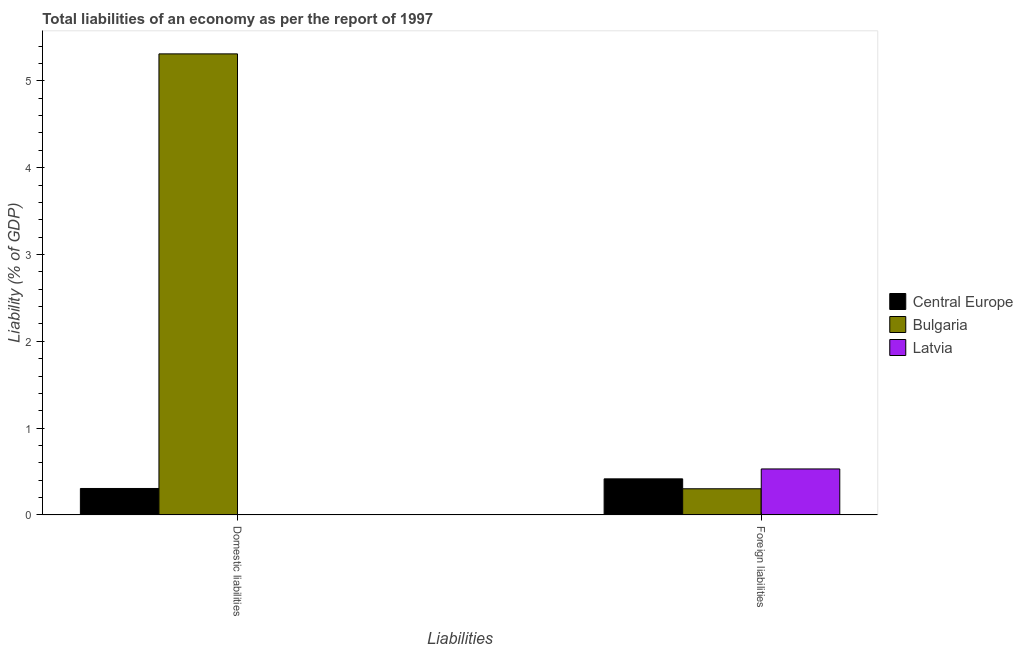How many different coloured bars are there?
Make the answer very short. 3. How many groups of bars are there?
Your response must be concise. 2. Are the number of bars per tick equal to the number of legend labels?
Keep it short and to the point. No. Are the number of bars on each tick of the X-axis equal?
Your response must be concise. No. How many bars are there on the 2nd tick from the right?
Give a very brief answer. 2. What is the label of the 2nd group of bars from the left?
Offer a terse response. Foreign liabilities. What is the incurrence of domestic liabilities in Bulgaria?
Make the answer very short. 5.31. Across all countries, what is the maximum incurrence of foreign liabilities?
Provide a short and direct response. 0.53. Across all countries, what is the minimum incurrence of domestic liabilities?
Your answer should be very brief. 0. In which country was the incurrence of foreign liabilities maximum?
Your answer should be very brief. Latvia. What is the total incurrence of foreign liabilities in the graph?
Your answer should be compact. 1.25. What is the difference between the incurrence of foreign liabilities in Latvia and that in Central Europe?
Give a very brief answer. 0.11. What is the difference between the incurrence of domestic liabilities in Latvia and the incurrence of foreign liabilities in Central Europe?
Offer a terse response. -0.42. What is the average incurrence of domestic liabilities per country?
Give a very brief answer. 1.87. What is the difference between the incurrence of foreign liabilities and incurrence of domestic liabilities in Central Europe?
Provide a short and direct response. 0.11. What is the ratio of the incurrence of foreign liabilities in Bulgaria to that in Central Europe?
Provide a succinct answer. 0.73. Is the incurrence of foreign liabilities in Central Europe less than that in Bulgaria?
Keep it short and to the point. No. Are all the bars in the graph horizontal?
Offer a very short reply. No. Are the values on the major ticks of Y-axis written in scientific E-notation?
Offer a very short reply. No. Does the graph contain grids?
Your answer should be very brief. No. How many legend labels are there?
Your answer should be compact. 3. How are the legend labels stacked?
Provide a succinct answer. Vertical. What is the title of the graph?
Give a very brief answer. Total liabilities of an economy as per the report of 1997. Does "Cuba" appear as one of the legend labels in the graph?
Offer a very short reply. No. What is the label or title of the X-axis?
Your answer should be very brief. Liabilities. What is the label or title of the Y-axis?
Offer a terse response. Liability (% of GDP). What is the Liability (% of GDP) in Central Europe in Domestic liabilities?
Give a very brief answer. 0.3. What is the Liability (% of GDP) of Bulgaria in Domestic liabilities?
Offer a terse response. 5.31. What is the Liability (% of GDP) in Central Europe in Foreign liabilities?
Your response must be concise. 0.42. What is the Liability (% of GDP) in Bulgaria in Foreign liabilities?
Make the answer very short. 0.3. What is the Liability (% of GDP) of Latvia in Foreign liabilities?
Provide a succinct answer. 0.53. Across all Liabilities, what is the maximum Liability (% of GDP) in Central Europe?
Provide a succinct answer. 0.42. Across all Liabilities, what is the maximum Liability (% of GDP) of Bulgaria?
Your answer should be compact. 5.31. Across all Liabilities, what is the maximum Liability (% of GDP) in Latvia?
Offer a very short reply. 0.53. Across all Liabilities, what is the minimum Liability (% of GDP) of Central Europe?
Your response must be concise. 0.3. Across all Liabilities, what is the minimum Liability (% of GDP) of Bulgaria?
Your answer should be very brief. 0.3. What is the total Liability (% of GDP) of Central Europe in the graph?
Offer a terse response. 0.72. What is the total Liability (% of GDP) of Bulgaria in the graph?
Provide a succinct answer. 5.61. What is the total Liability (% of GDP) of Latvia in the graph?
Ensure brevity in your answer.  0.53. What is the difference between the Liability (% of GDP) in Central Europe in Domestic liabilities and that in Foreign liabilities?
Provide a short and direct response. -0.11. What is the difference between the Liability (% of GDP) in Bulgaria in Domestic liabilities and that in Foreign liabilities?
Keep it short and to the point. 5.01. What is the difference between the Liability (% of GDP) in Central Europe in Domestic liabilities and the Liability (% of GDP) in Bulgaria in Foreign liabilities?
Your answer should be very brief. 0. What is the difference between the Liability (% of GDP) in Central Europe in Domestic liabilities and the Liability (% of GDP) in Latvia in Foreign liabilities?
Your answer should be very brief. -0.22. What is the difference between the Liability (% of GDP) of Bulgaria in Domestic liabilities and the Liability (% of GDP) of Latvia in Foreign liabilities?
Offer a terse response. 4.78. What is the average Liability (% of GDP) of Central Europe per Liabilities?
Ensure brevity in your answer.  0.36. What is the average Liability (% of GDP) in Bulgaria per Liabilities?
Your answer should be compact. 2.81. What is the average Liability (% of GDP) in Latvia per Liabilities?
Your answer should be very brief. 0.26. What is the difference between the Liability (% of GDP) of Central Europe and Liability (% of GDP) of Bulgaria in Domestic liabilities?
Give a very brief answer. -5.01. What is the difference between the Liability (% of GDP) in Central Europe and Liability (% of GDP) in Bulgaria in Foreign liabilities?
Ensure brevity in your answer.  0.11. What is the difference between the Liability (% of GDP) in Central Europe and Liability (% of GDP) in Latvia in Foreign liabilities?
Keep it short and to the point. -0.11. What is the difference between the Liability (% of GDP) of Bulgaria and Liability (% of GDP) of Latvia in Foreign liabilities?
Ensure brevity in your answer.  -0.23. What is the ratio of the Liability (% of GDP) of Central Europe in Domestic liabilities to that in Foreign liabilities?
Offer a very short reply. 0.73. What is the ratio of the Liability (% of GDP) of Bulgaria in Domestic liabilities to that in Foreign liabilities?
Provide a short and direct response. 17.62. What is the difference between the highest and the second highest Liability (% of GDP) in Central Europe?
Your answer should be compact. 0.11. What is the difference between the highest and the second highest Liability (% of GDP) of Bulgaria?
Keep it short and to the point. 5.01. What is the difference between the highest and the lowest Liability (% of GDP) of Central Europe?
Provide a succinct answer. 0.11. What is the difference between the highest and the lowest Liability (% of GDP) of Bulgaria?
Provide a short and direct response. 5.01. What is the difference between the highest and the lowest Liability (% of GDP) of Latvia?
Provide a short and direct response. 0.53. 